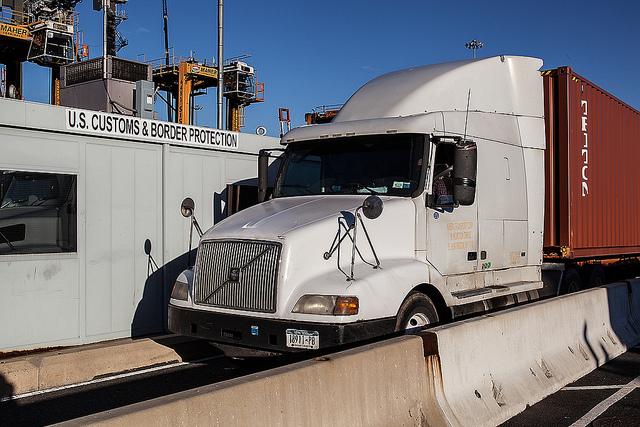What is the purpose of this traffic stop?
Short answer required. Customs. What type of vehicle is this?
Be succinct. Truck. Is this truck being inspected for illegal cargo?
Short answer required. Yes. 